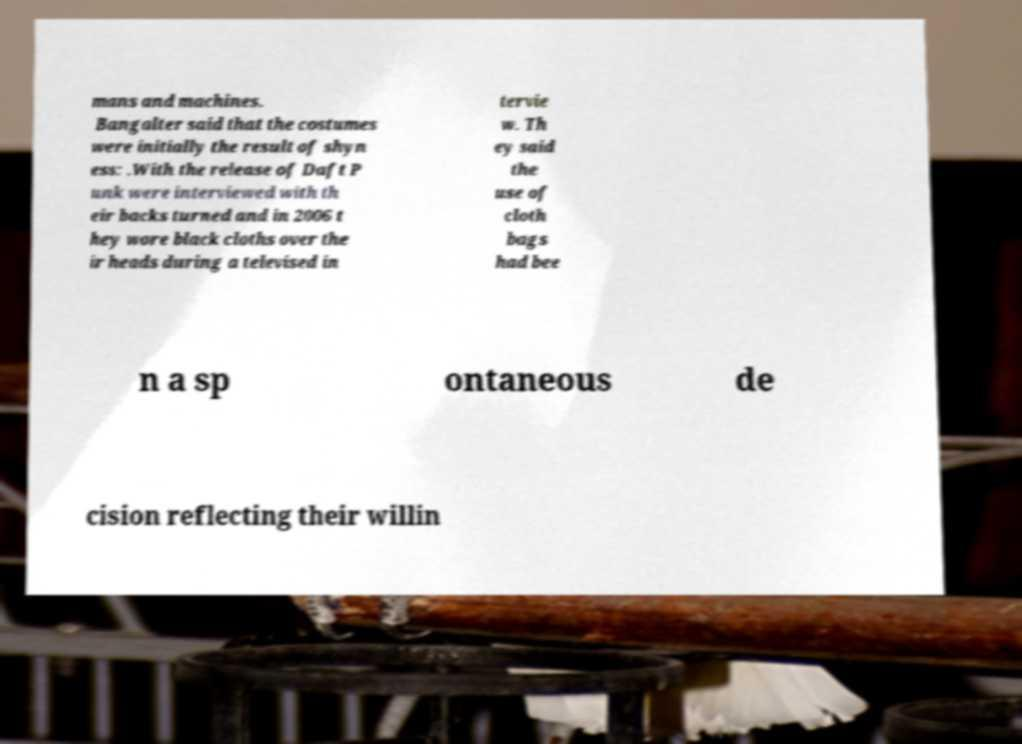What messages or text are displayed in this image? I need them in a readable, typed format. mans and machines. Bangalter said that the costumes were initially the result of shyn ess: .With the release of Daft P unk were interviewed with th eir backs turned and in 2006 t hey wore black cloths over the ir heads during a televised in tervie w. Th ey said the use of cloth bags had bee n a sp ontaneous de cision reflecting their willin 